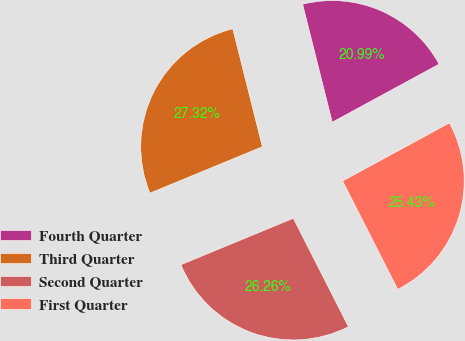Convert chart to OTSL. <chart><loc_0><loc_0><loc_500><loc_500><pie_chart><fcel>Fourth Quarter<fcel>Third Quarter<fcel>Second Quarter<fcel>First Quarter<nl><fcel>20.99%<fcel>27.32%<fcel>26.26%<fcel>25.43%<nl></chart> 